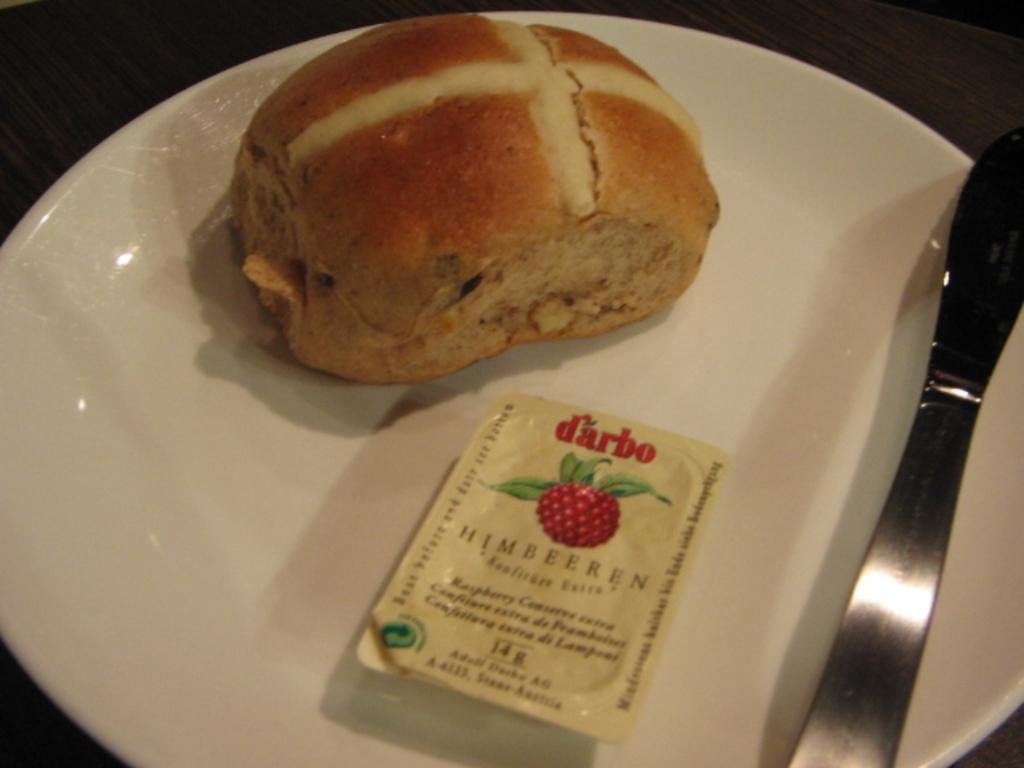What is on the plate that is visible in the image? There is a burger on the plate in the image. What color is the plate? The plate is white. What utensil is present on the plate? There is a knife on the plate. What hobbies does the burger have in the image? The burger is an inanimate object and does not have hobbies. 